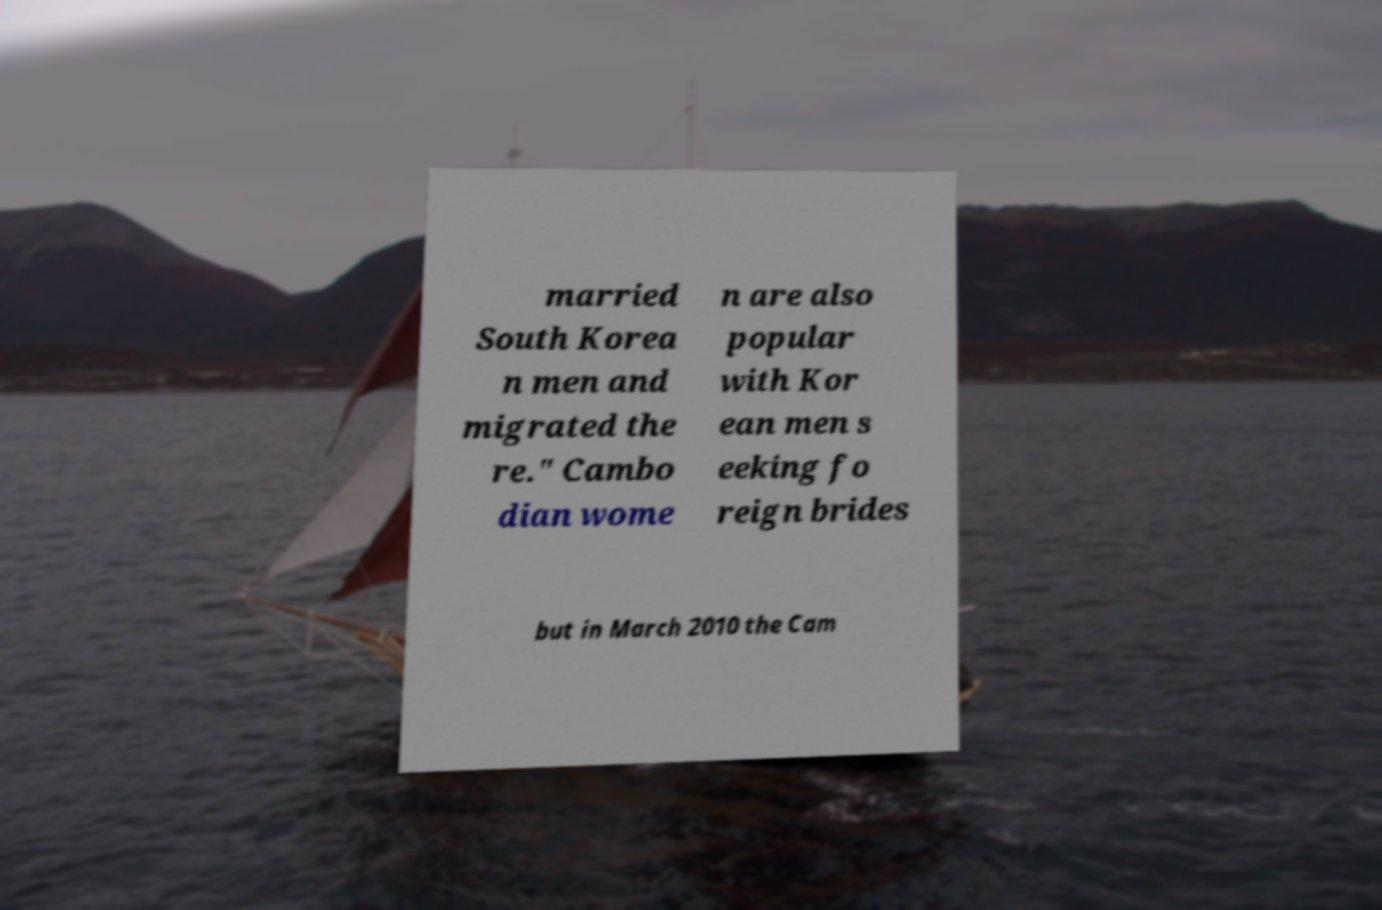Can you accurately transcribe the text from the provided image for me? married South Korea n men and migrated the re." Cambo dian wome n are also popular with Kor ean men s eeking fo reign brides but in March 2010 the Cam 